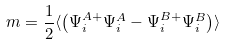Convert formula to latex. <formula><loc_0><loc_0><loc_500><loc_500>m = \frac { 1 } { 2 } \langle \left ( \Psi ^ { A + } _ { i } \Psi ^ { A } _ { i } - \Psi ^ { B + } _ { i } \Psi ^ { B } _ { i } \right ) \rangle</formula> 